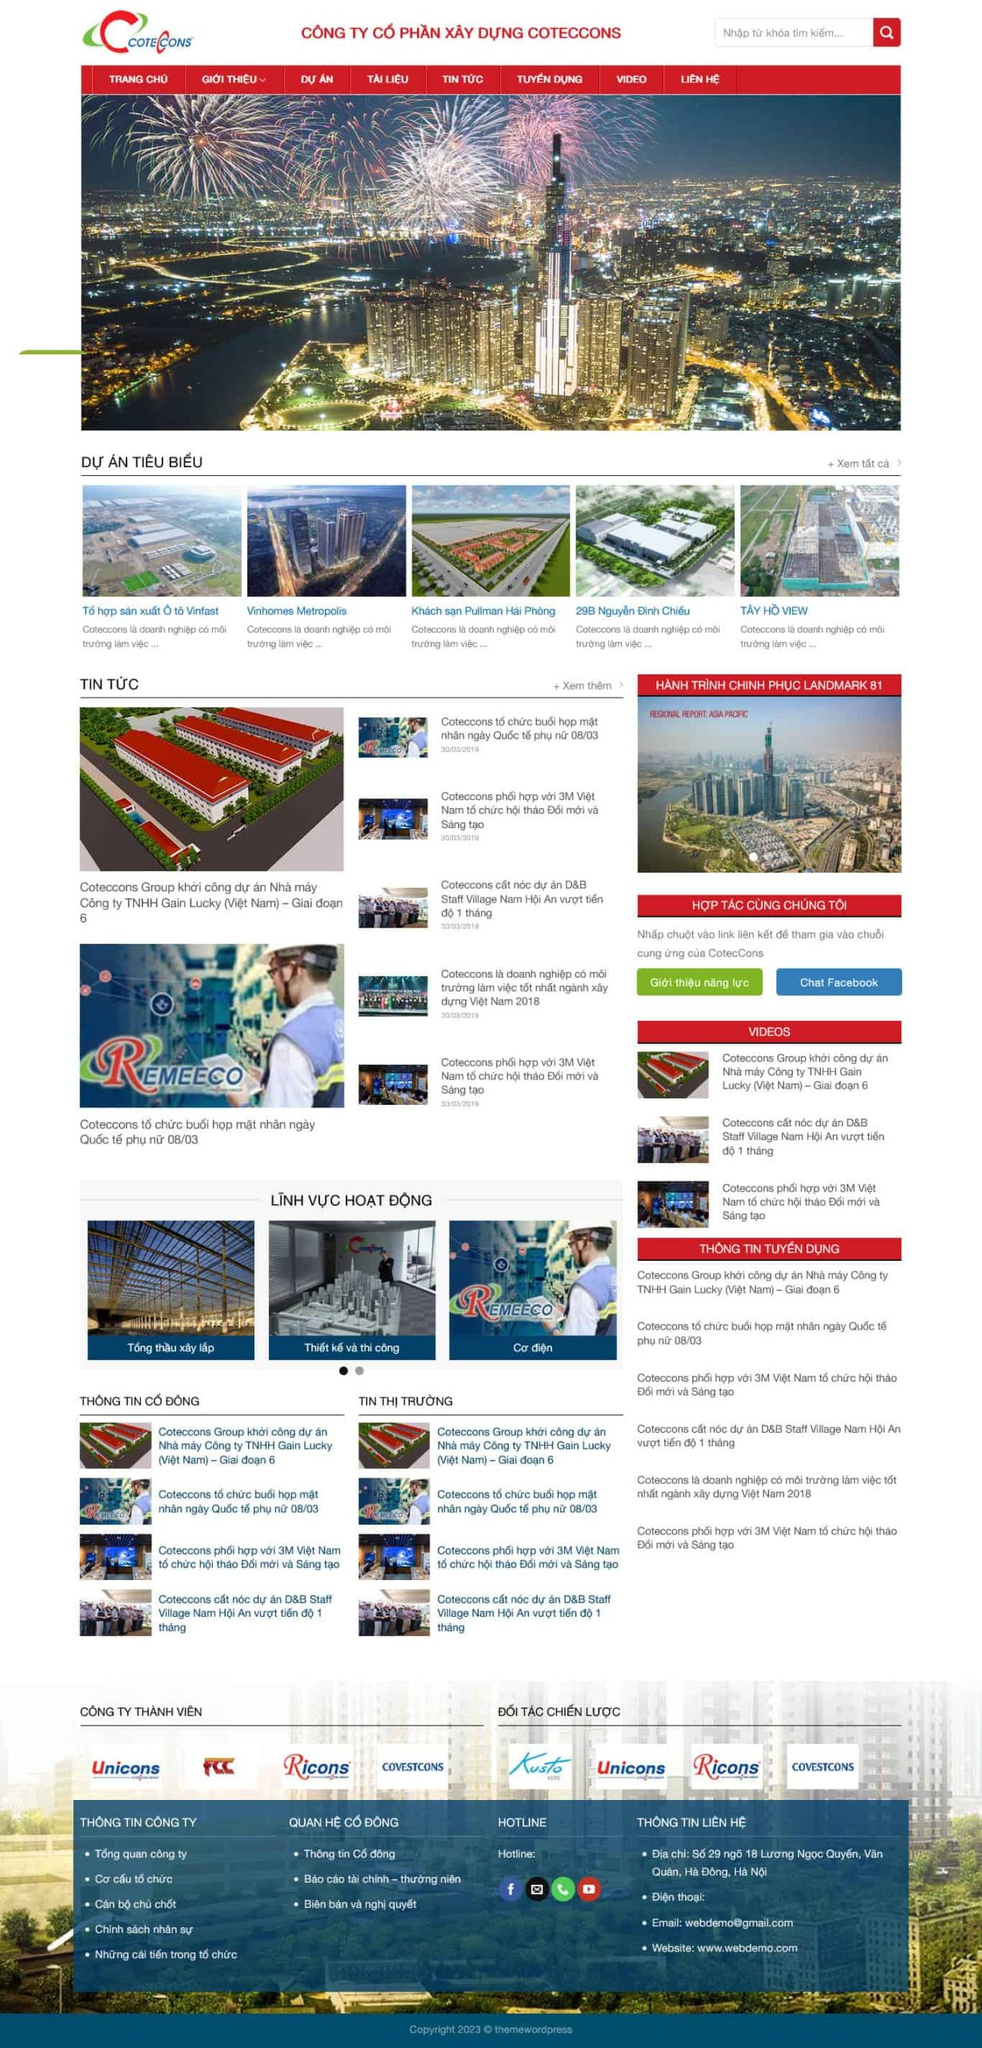Liệt kê 5 ngành nghề, lĩnh vực phù hợp với website này, phân cách các màu sắc bằng dấu phẩy. Chỉ trả về kết quả, phân cách bằng dấy phẩy
 Xây dựng, Thiết kế kiến trúc, Cơ điện, Tổng thầu xây lắp, Dự án bất động sản 